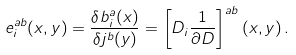Convert formula to latex. <formula><loc_0><loc_0><loc_500><loc_500>e _ { i } ^ { a b } ( x , y ) = \frac { \delta b ^ { a } _ { i } ( x ) } { \delta j ^ { b } ( y ) } = \left [ { D } _ { i } \frac { 1 } { \partial { D } } \right ] ^ { a b } ( x , y ) \, .</formula> 